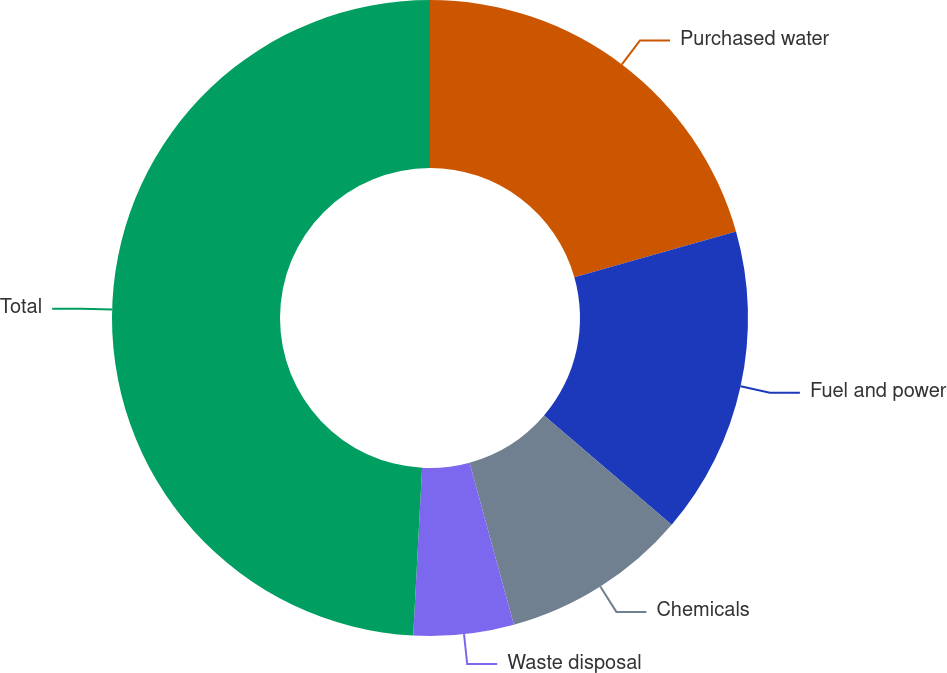<chart> <loc_0><loc_0><loc_500><loc_500><pie_chart><fcel>Purchased water<fcel>Fuel and power<fcel>Chemicals<fcel>Waste disposal<fcel>Total<nl><fcel>20.62%<fcel>15.64%<fcel>9.49%<fcel>5.09%<fcel>49.16%<nl></chart> 